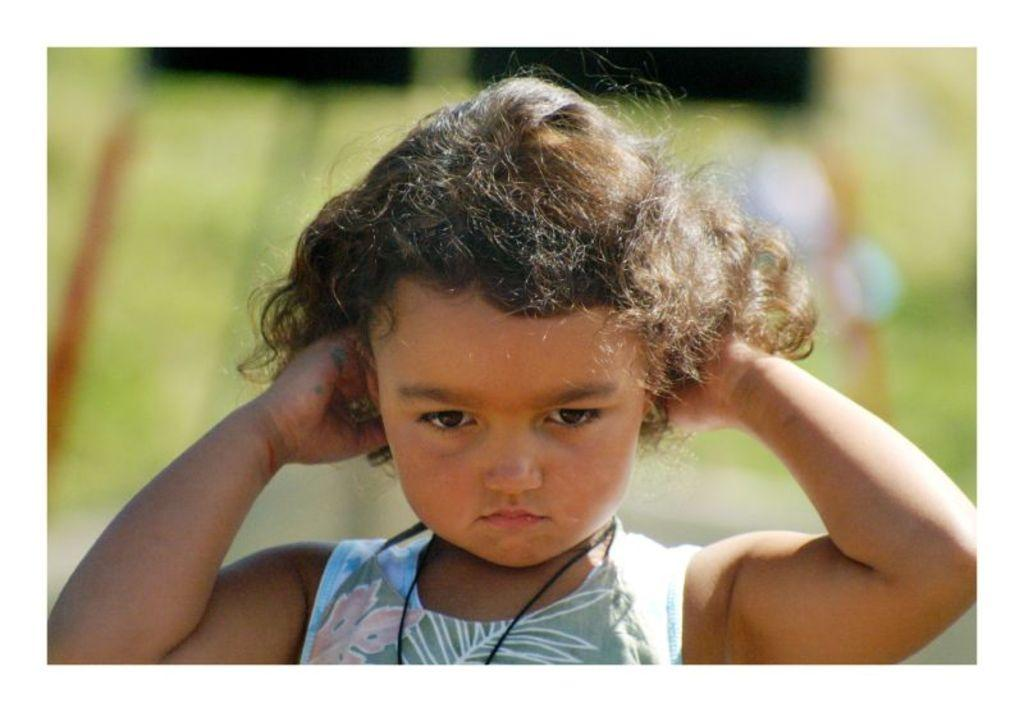Who or what is the main subject in the image? There is a person in the image. What is the person wearing? The person is wearing a white and gray color dress. Can you describe the background of the image? The background of the image is blurred. What type of knowledge can be gained from the grass in the image? There is no grass present in the image, so no knowledge can be gained from it. 